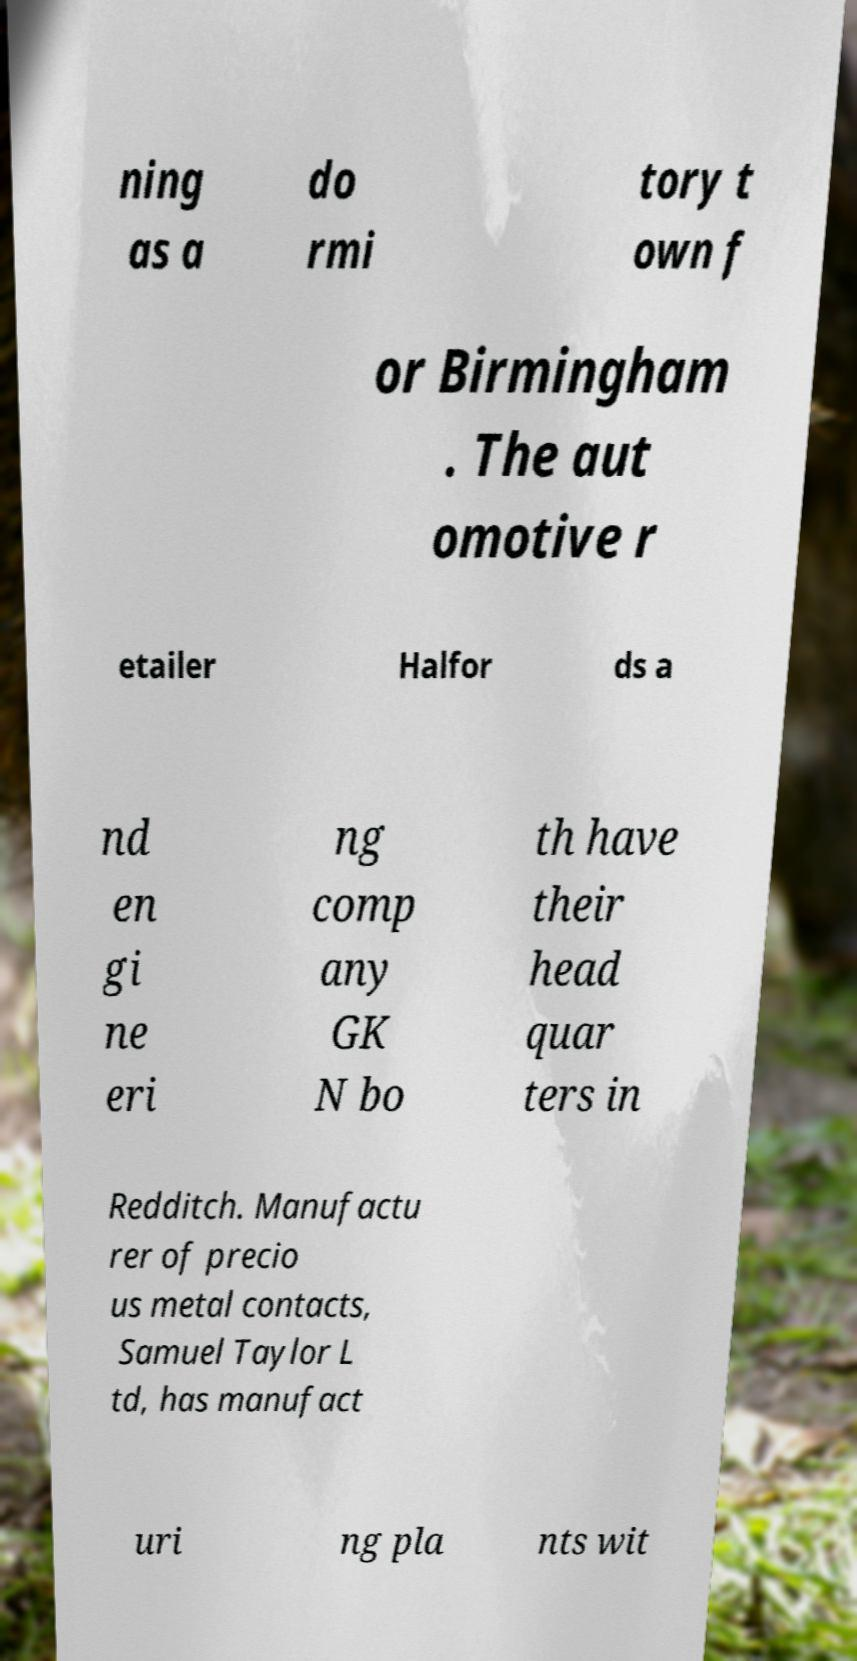Please read and relay the text visible in this image. What does it say? ning as a do rmi tory t own f or Birmingham . The aut omotive r etailer Halfor ds a nd en gi ne eri ng comp any GK N bo th have their head quar ters in Redditch. Manufactu rer of precio us metal contacts, Samuel Taylor L td, has manufact uri ng pla nts wit 